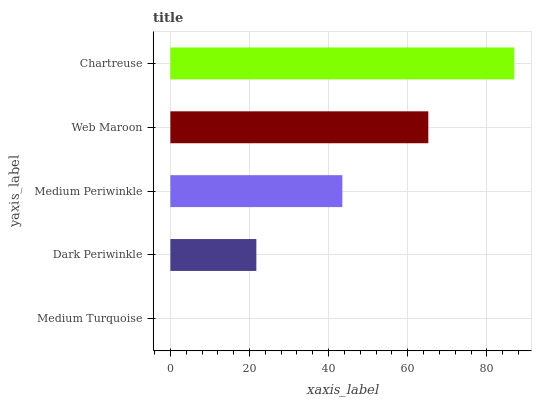Is Medium Turquoise the minimum?
Answer yes or no. Yes. Is Chartreuse the maximum?
Answer yes or no. Yes. Is Dark Periwinkle the minimum?
Answer yes or no. No. Is Dark Periwinkle the maximum?
Answer yes or no. No. Is Dark Periwinkle greater than Medium Turquoise?
Answer yes or no. Yes. Is Medium Turquoise less than Dark Periwinkle?
Answer yes or no. Yes. Is Medium Turquoise greater than Dark Periwinkle?
Answer yes or no. No. Is Dark Periwinkle less than Medium Turquoise?
Answer yes or no. No. Is Medium Periwinkle the high median?
Answer yes or no. Yes. Is Medium Periwinkle the low median?
Answer yes or no. Yes. Is Dark Periwinkle the high median?
Answer yes or no. No. Is Medium Turquoise the low median?
Answer yes or no. No. 